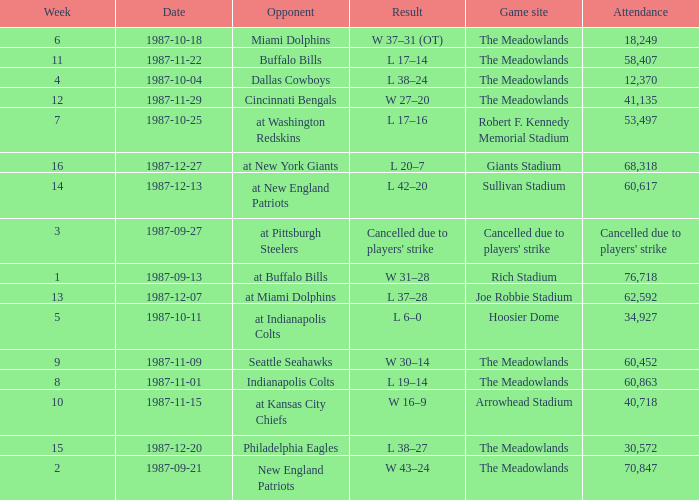Who did the Jets play in their post-week 15 game? At new york giants. 